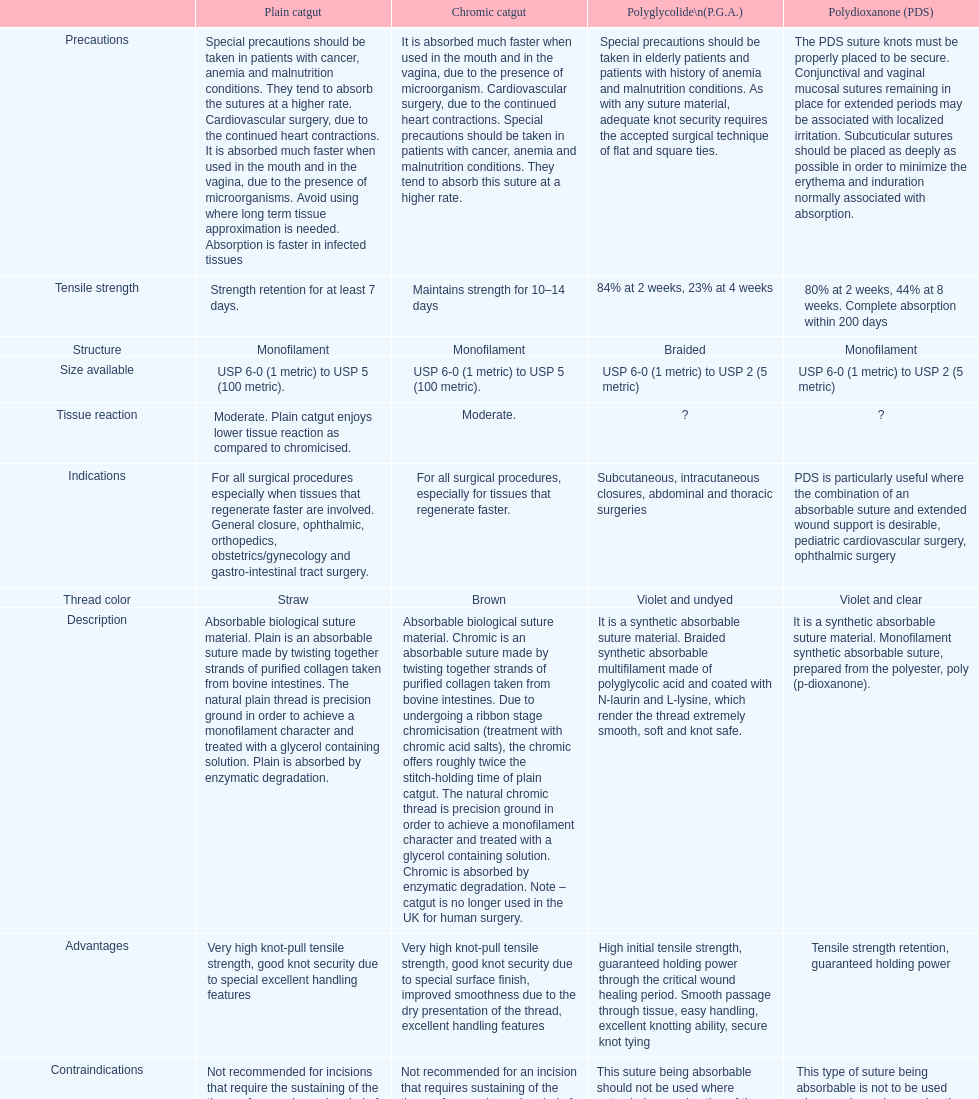Plain catgut and chromic catgut both have what type of structure? Monofilament. 